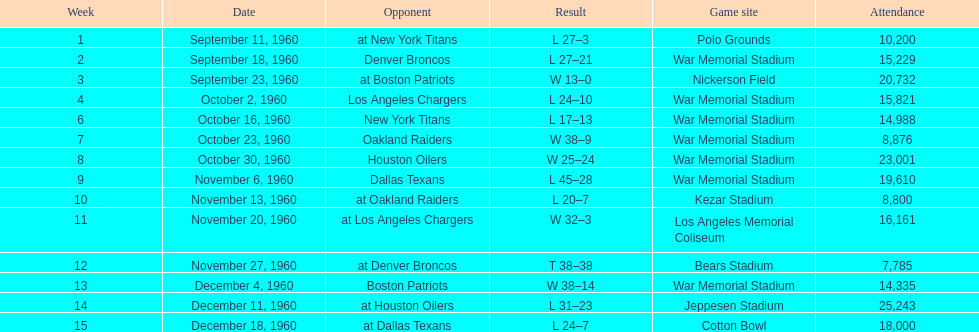The total number of games played at war memorial stadium was how many? 7. 